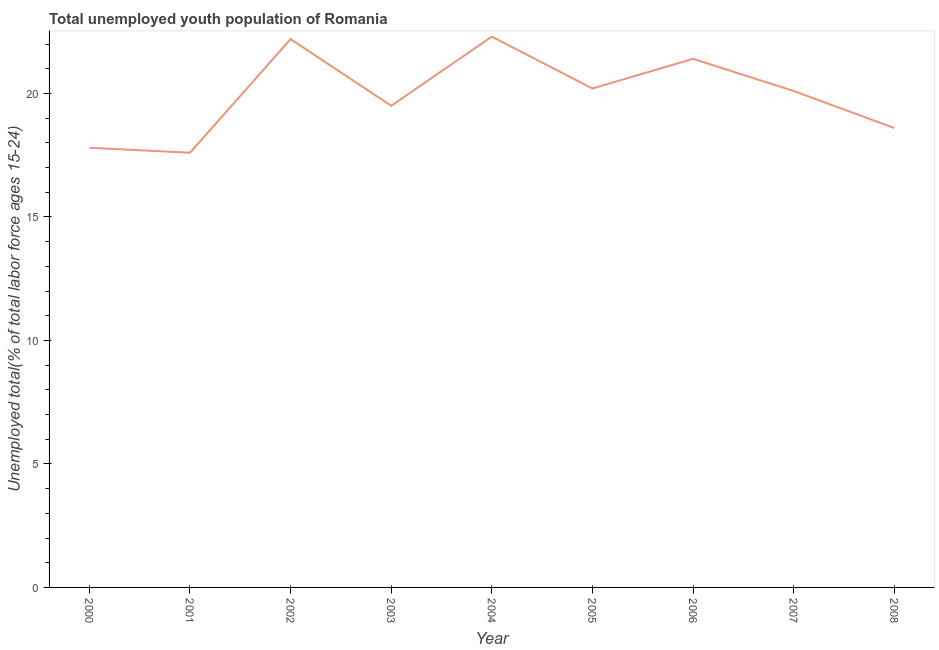What is the unemployed youth in 2001?
Offer a terse response. 17.6. Across all years, what is the maximum unemployed youth?
Offer a very short reply. 22.3. Across all years, what is the minimum unemployed youth?
Your response must be concise. 17.6. In which year was the unemployed youth minimum?
Provide a short and direct response. 2001. What is the sum of the unemployed youth?
Provide a short and direct response. 179.7. What is the difference between the unemployed youth in 2004 and 2005?
Your response must be concise. 2.1. What is the average unemployed youth per year?
Your answer should be compact. 19.97. What is the median unemployed youth?
Keep it short and to the point. 20.1. What is the ratio of the unemployed youth in 2003 to that in 2004?
Your response must be concise. 0.87. Is the unemployed youth in 2005 less than that in 2007?
Your response must be concise. No. Is the difference between the unemployed youth in 2005 and 2008 greater than the difference between any two years?
Your answer should be compact. No. What is the difference between the highest and the second highest unemployed youth?
Provide a short and direct response. 0.1. Is the sum of the unemployed youth in 2003 and 2008 greater than the maximum unemployed youth across all years?
Your response must be concise. Yes. What is the difference between the highest and the lowest unemployed youth?
Offer a terse response. 4.7. In how many years, is the unemployed youth greater than the average unemployed youth taken over all years?
Your answer should be very brief. 5. Does the unemployed youth monotonically increase over the years?
Ensure brevity in your answer.  No. How many years are there in the graph?
Provide a short and direct response. 9. What is the difference between two consecutive major ticks on the Y-axis?
Keep it short and to the point. 5. Are the values on the major ticks of Y-axis written in scientific E-notation?
Keep it short and to the point. No. Does the graph contain any zero values?
Make the answer very short. No. What is the title of the graph?
Ensure brevity in your answer.  Total unemployed youth population of Romania. What is the label or title of the Y-axis?
Offer a very short reply. Unemployed total(% of total labor force ages 15-24). What is the Unemployed total(% of total labor force ages 15-24) in 2000?
Offer a terse response. 17.8. What is the Unemployed total(% of total labor force ages 15-24) in 2001?
Ensure brevity in your answer.  17.6. What is the Unemployed total(% of total labor force ages 15-24) in 2002?
Make the answer very short. 22.2. What is the Unemployed total(% of total labor force ages 15-24) of 2004?
Give a very brief answer. 22.3. What is the Unemployed total(% of total labor force ages 15-24) of 2005?
Your answer should be compact. 20.2. What is the Unemployed total(% of total labor force ages 15-24) in 2006?
Offer a very short reply. 21.4. What is the Unemployed total(% of total labor force ages 15-24) in 2007?
Provide a short and direct response. 20.1. What is the Unemployed total(% of total labor force ages 15-24) of 2008?
Your answer should be very brief. 18.6. What is the difference between the Unemployed total(% of total labor force ages 15-24) in 2000 and 2003?
Offer a terse response. -1.7. What is the difference between the Unemployed total(% of total labor force ages 15-24) in 2000 and 2004?
Offer a terse response. -4.5. What is the difference between the Unemployed total(% of total labor force ages 15-24) in 2000 and 2005?
Ensure brevity in your answer.  -2.4. What is the difference between the Unemployed total(% of total labor force ages 15-24) in 2000 and 2006?
Provide a succinct answer. -3.6. What is the difference between the Unemployed total(% of total labor force ages 15-24) in 2001 and 2003?
Keep it short and to the point. -1.9. What is the difference between the Unemployed total(% of total labor force ages 15-24) in 2001 and 2004?
Provide a succinct answer. -4.7. What is the difference between the Unemployed total(% of total labor force ages 15-24) in 2002 and 2004?
Offer a very short reply. -0.1. What is the difference between the Unemployed total(% of total labor force ages 15-24) in 2002 and 2005?
Offer a very short reply. 2. What is the difference between the Unemployed total(% of total labor force ages 15-24) in 2002 and 2006?
Ensure brevity in your answer.  0.8. What is the difference between the Unemployed total(% of total labor force ages 15-24) in 2002 and 2008?
Your answer should be compact. 3.6. What is the difference between the Unemployed total(% of total labor force ages 15-24) in 2003 and 2004?
Make the answer very short. -2.8. What is the difference between the Unemployed total(% of total labor force ages 15-24) in 2003 and 2005?
Provide a short and direct response. -0.7. What is the difference between the Unemployed total(% of total labor force ages 15-24) in 2004 and 2005?
Ensure brevity in your answer.  2.1. What is the difference between the Unemployed total(% of total labor force ages 15-24) in 2004 and 2006?
Ensure brevity in your answer.  0.9. What is the difference between the Unemployed total(% of total labor force ages 15-24) in 2007 and 2008?
Your response must be concise. 1.5. What is the ratio of the Unemployed total(% of total labor force ages 15-24) in 2000 to that in 2001?
Give a very brief answer. 1.01. What is the ratio of the Unemployed total(% of total labor force ages 15-24) in 2000 to that in 2002?
Offer a terse response. 0.8. What is the ratio of the Unemployed total(% of total labor force ages 15-24) in 2000 to that in 2003?
Provide a succinct answer. 0.91. What is the ratio of the Unemployed total(% of total labor force ages 15-24) in 2000 to that in 2004?
Ensure brevity in your answer.  0.8. What is the ratio of the Unemployed total(% of total labor force ages 15-24) in 2000 to that in 2005?
Ensure brevity in your answer.  0.88. What is the ratio of the Unemployed total(% of total labor force ages 15-24) in 2000 to that in 2006?
Provide a short and direct response. 0.83. What is the ratio of the Unemployed total(% of total labor force ages 15-24) in 2000 to that in 2007?
Your response must be concise. 0.89. What is the ratio of the Unemployed total(% of total labor force ages 15-24) in 2001 to that in 2002?
Your answer should be very brief. 0.79. What is the ratio of the Unemployed total(% of total labor force ages 15-24) in 2001 to that in 2003?
Your response must be concise. 0.9. What is the ratio of the Unemployed total(% of total labor force ages 15-24) in 2001 to that in 2004?
Ensure brevity in your answer.  0.79. What is the ratio of the Unemployed total(% of total labor force ages 15-24) in 2001 to that in 2005?
Your response must be concise. 0.87. What is the ratio of the Unemployed total(% of total labor force ages 15-24) in 2001 to that in 2006?
Your answer should be compact. 0.82. What is the ratio of the Unemployed total(% of total labor force ages 15-24) in 2001 to that in 2007?
Your response must be concise. 0.88. What is the ratio of the Unemployed total(% of total labor force ages 15-24) in 2001 to that in 2008?
Offer a terse response. 0.95. What is the ratio of the Unemployed total(% of total labor force ages 15-24) in 2002 to that in 2003?
Your response must be concise. 1.14. What is the ratio of the Unemployed total(% of total labor force ages 15-24) in 2002 to that in 2004?
Your answer should be very brief. 1. What is the ratio of the Unemployed total(% of total labor force ages 15-24) in 2002 to that in 2005?
Provide a succinct answer. 1.1. What is the ratio of the Unemployed total(% of total labor force ages 15-24) in 2002 to that in 2006?
Give a very brief answer. 1.04. What is the ratio of the Unemployed total(% of total labor force ages 15-24) in 2002 to that in 2007?
Make the answer very short. 1.1. What is the ratio of the Unemployed total(% of total labor force ages 15-24) in 2002 to that in 2008?
Keep it short and to the point. 1.19. What is the ratio of the Unemployed total(% of total labor force ages 15-24) in 2003 to that in 2004?
Give a very brief answer. 0.87. What is the ratio of the Unemployed total(% of total labor force ages 15-24) in 2003 to that in 2005?
Your answer should be compact. 0.96. What is the ratio of the Unemployed total(% of total labor force ages 15-24) in 2003 to that in 2006?
Give a very brief answer. 0.91. What is the ratio of the Unemployed total(% of total labor force ages 15-24) in 2003 to that in 2007?
Make the answer very short. 0.97. What is the ratio of the Unemployed total(% of total labor force ages 15-24) in 2003 to that in 2008?
Make the answer very short. 1.05. What is the ratio of the Unemployed total(% of total labor force ages 15-24) in 2004 to that in 2005?
Your answer should be compact. 1.1. What is the ratio of the Unemployed total(% of total labor force ages 15-24) in 2004 to that in 2006?
Offer a very short reply. 1.04. What is the ratio of the Unemployed total(% of total labor force ages 15-24) in 2004 to that in 2007?
Keep it short and to the point. 1.11. What is the ratio of the Unemployed total(% of total labor force ages 15-24) in 2004 to that in 2008?
Ensure brevity in your answer.  1.2. What is the ratio of the Unemployed total(% of total labor force ages 15-24) in 2005 to that in 2006?
Your answer should be compact. 0.94. What is the ratio of the Unemployed total(% of total labor force ages 15-24) in 2005 to that in 2008?
Your answer should be very brief. 1.09. What is the ratio of the Unemployed total(% of total labor force ages 15-24) in 2006 to that in 2007?
Offer a very short reply. 1.06. What is the ratio of the Unemployed total(% of total labor force ages 15-24) in 2006 to that in 2008?
Offer a terse response. 1.15. What is the ratio of the Unemployed total(% of total labor force ages 15-24) in 2007 to that in 2008?
Offer a very short reply. 1.08. 